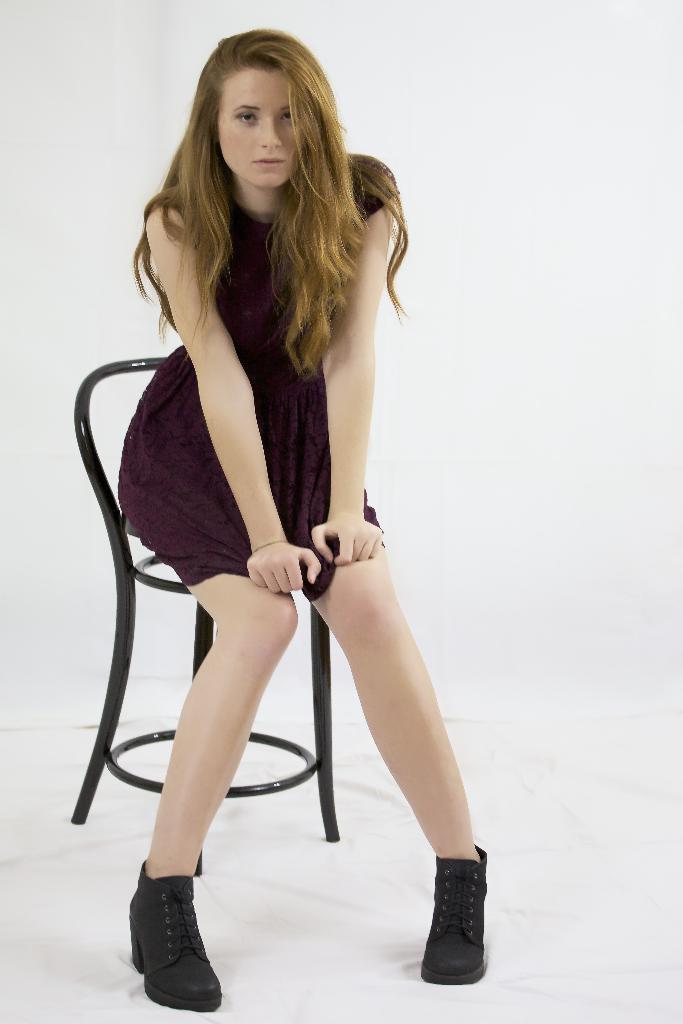Can you describe this image briefly? In this image we can see a lady sitting on the chair. 